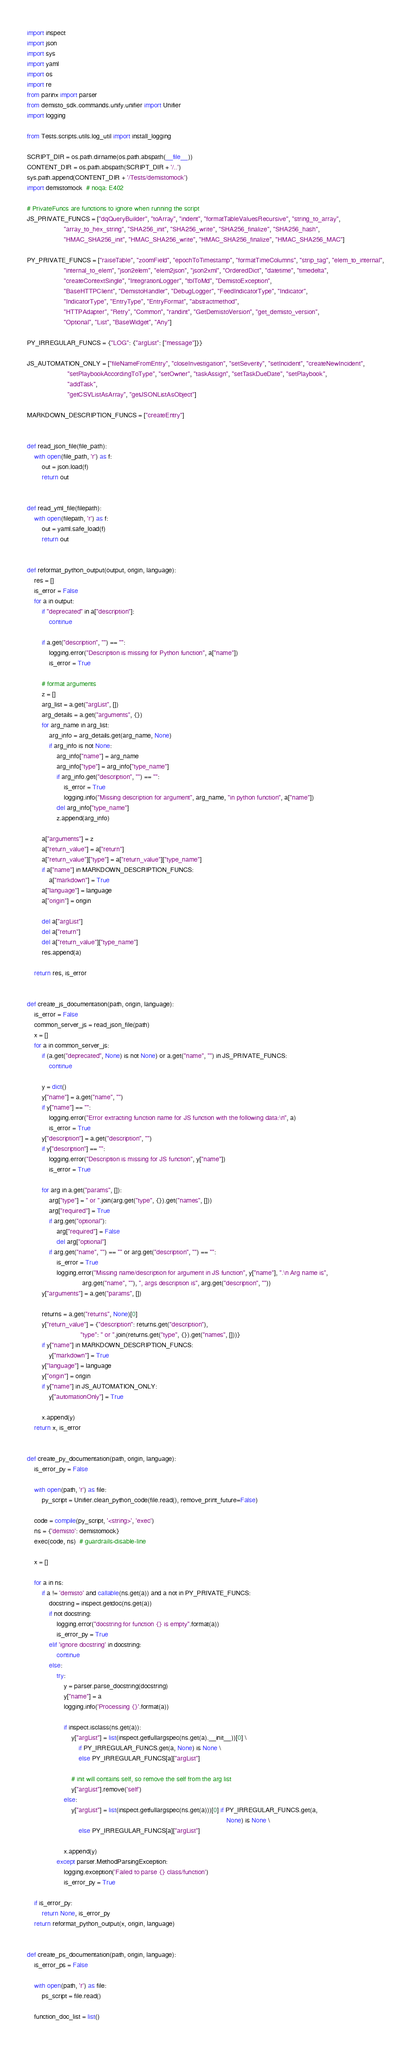<code> <loc_0><loc_0><loc_500><loc_500><_Python_>import inspect
import json
import sys
import yaml
import os
import re
from parinx import parser
from demisto_sdk.commands.unify.unifier import Unifier
import logging

from Tests.scripts.utils.log_util import install_logging

SCRIPT_DIR = os.path.dirname(os.path.abspath(__file__))
CONTENT_DIR = os.path.abspath(SCRIPT_DIR + '/..')
sys.path.append(CONTENT_DIR + '/Tests/demistomock')
import demistomock  # noqa: E402

# PrivateFuncs are functions to ignore when running the script
JS_PRIVATE_FUNCS = ["dqQueryBuilder", "toArray", "indent", "formatTableValuesRecursive", "string_to_array",
                    "array_to_hex_string", "SHA256_init", "SHA256_write", "SHA256_finalize", "SHA256_hash",
                    "HMAC_SHA256_init", "HMAC_SHA256_write", "HMAC_SHA256_finalize", "HMAC_SHA256_MAC"]

PY_PRIVATE_FUNCS = ["raiseTable", "zoomField", "epochToTimestamp", "formatTimeColumns", "strip_tag", "elem_to_internal",
                    "internal_to_elem", "json2elem", "elem2json", "json2xml", "OrderedDict", "datetime", "timedelta",
                    "createContextSingle", "IntegrationLogger", "tblToMd", "DemistoException",
                    "BaseHTTPClient", "DemistoHandler", "DebugLogger", "FeedIndicatorType", "Indicator",
                    "IndicatorType", "EntryType", "EntryFormat", "abstractmethod",
                    "HTTPAdapter", "Retry", "Common", "randint", "GetDemistoVersion", "get_demisto_version",
                    "Optional", "List", "BaseWidget", "Any"]

PY_IRREGULAR_FUNCS = {"LOG": {"argList": ["message"]}}

JS_AUTOMATION_ONLY = ["fileNameFromEntry", "closeInvestigation", "setSeverity", "setIncident", "createNewIncident",
                      "setPlaybookAccordingToType", "setOwner", "taskAssign", "setTaskDueDate", "setPlaybook",
                      "addTask",
                      "getCSVListAsArray", "getJSONListAsObject"]

MARKDOWN_DESCRIPTION_FUNCS = ["createEntry"]


def read_json_file(file_path):
    with open(file_path, 'r') as f:
        out = json.load(f)
        return out


def read_yml_file(filepath):
    with open(filepath, 'r') as f:
        out = yaml.safe_load(f)
        return out


def reformat_python_output(output, origin, language):
    res = []
    is_error = False
    for a in output:
        if "deprecated" in a["description"]:
            continue

        if a.get("description", "") == "":
            logging.error("Description is missing for Python function", a["name"])
            is_error = True

        # format arguments
        z = []
        arg_list = a.get("argList", [])
        arg_details = a.get("arguments", {})
        for arg_name in arg_list:
            arg_info = arg_details.get(arg_name, None)
            if arg_info is not None:
                arg_info["name"] = arg_name
                arg_info["type"] = arg_info["type_name"]
                if arg_info.get("description", "") == "":
                    is_error = True
                    logging.info("Missing description for argument", arg_name, "in python function", a["name"])
                del arg_info["type_name"]
                z.append(arg_info)

        a["arguments"] = z
        a["return_value"] = a["return"]
        a["return_value"]["type"] = a["return_value"]["type_name"]
        if a["name"] in MARKDOWN_DESCRIPTION_FUNCS:
            a["markdown"] = True
        a["language"] = language
        a["origin"] = origin

        del a["argList"]
        del a["return"]
        del a["return_value"]["type_name"]
        res.append(a)

    return res, is_error


def create_js_documentation(path, origin, language):
    is_error = False
    common_server_js = read_json_file(path)
    x = []
    for a in common_server_js:
        if (a.get("deprecated", None) is not None) or a.get("name", "") in JS_PRIVATE_FUNCS:
            continue

        y = dict()
        y["name"] = a.get("name", "")
        if y["name"] == "":
            logging.error("Error extracting function name for JS function with the following data:\n", a)
            is_error = True
        y["description"] = a.get("description", "")
        if y["description"] == "":
            logging.error("Description is missing for JS function", y["name"])
            is_error = True

        for arg in a.get("params", []):
            arg["type"] = " or ".join(arg.get("type", {}).get("names", []))
            arg["required"] = True
            if arg.get("optional"):
                arg["required"] = False
                del arg["optional"]
            if arg.get("name", "") == "" or arg.get("description", "") == "":
                is_error = True
                logging.error("Missing name/description for argument in JS function", y["name"], ".\n Arg name is",
                              arg.get("name", ""), ", args description is", arg.get("description", ""))
        y["arguments"] = a.get("params", [])

        returns = a.get("returns", None)[0]
        y["return_value"] = {"description": returns.get("description"),
                             "type": " or ".join(returns.get("type", {}).get("names", []))}
        if y["name"] in MARKDOWN_DESCRIPTION_FUNCS:
            y["markdown"] = True
        y["language"] = language
        y["origin"] = origin
        if y["name"] in JS_AUTOMATION_ONLY:
            y["automationOnly"] = True

        x.append(y)
    return x, is_error


def create_py_documentation(path, origin, language):
    is_error_py = False

    with open(path, 'r') as file:
        py_script = Unifier.clean_python_code(file.read(), remove_print_future=False)

    code = compile(py_script, '<string>', 'exec')
    ns = {'demisto': demistomock}
    exec(code, ns)  # guardrails-disable-line

    x = []

    for a in ns:
        if a != 'demisto' and callable(ns.get(a)) and a not in PY_PRIVATE_FUNCS:
            docstring = inspect.getdoc(ns.get(a))
            if not docstring:
                logging.error("docstring for function {} is empty".format(a))
                is_error_py = True
            elif 'ignore docstring' in docstring:
                continue
            else:
                try:
                    y = parser.parse_docstring(docstring)
                    y["name"] = a
                    logging.info('Processing {}'.format(a))

                    if inspect.isclass(ns.get(a)):
                        y["argList"] = list(inspect.getfullargspec(ns.get(a).__init__))[0] \
                            if PY_IRREGULAR_FUNCS.get(a, None) is None \
                            else PY_IRREGULAR_FUNCS[a]["argList"]

                        # init will contains self, so remove the self from the arg list
                        y["argList"].remove('self')
                    else:
                        y["argList"] = list(inspect.getfullargspec(ns.get(a)))[0] if PY_IRREGULAR_FUNCS.get(a,
                                                                                                            None) is None \
                            else PY_IRREGULAR_FUNCS[a]["argList"]

                    x.append(y)
                except parser.MethodParsingException:
                    logging.exception('Failed to parse {} class/function')
                    is_error_py = True

    if is_error_py:
        return None, is_error_py
    return reformat_python_output(x, origin, language)


def create_ps_documentation(path, origin, language):
    is_error_ps = False

    with open(path, 'r') as file:
        ps_script = file.read()

    function_doc_list = list()</code> 